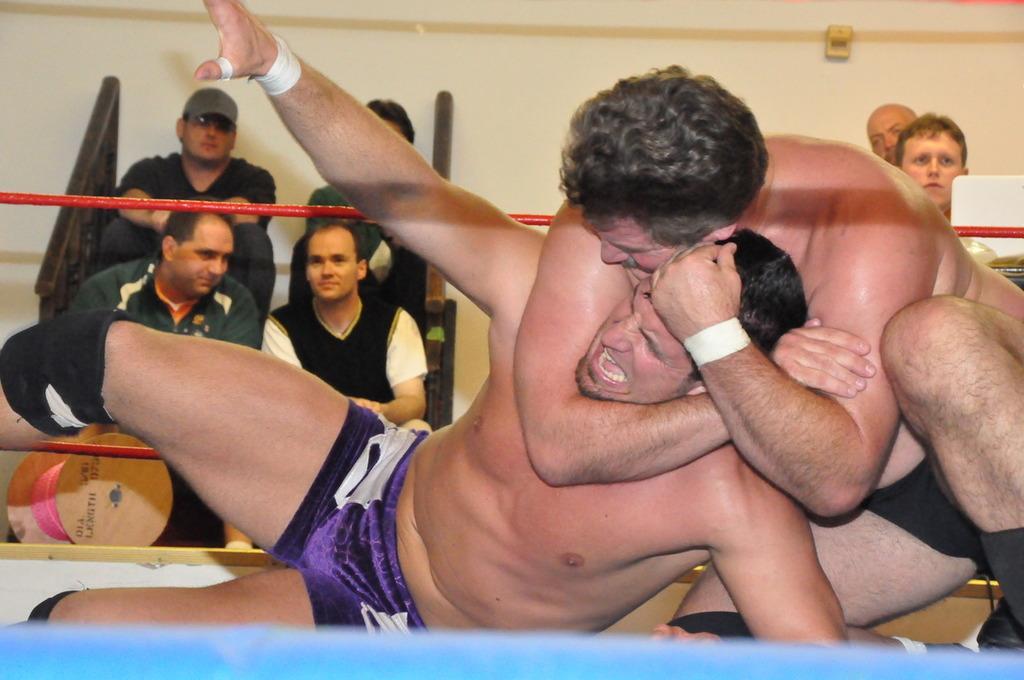How would you summarize this image in a sentence or two? In this image there are two persons fighting with each other in a wrestling ring, behind them there are few spectators. 